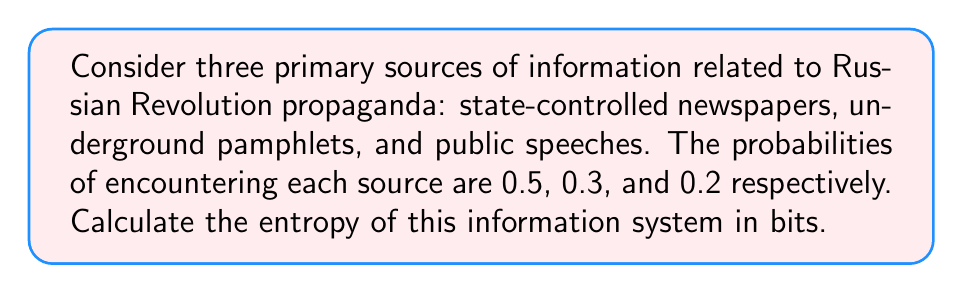Show me your answer to this math problem. To calculate the entropy of this information system, we'll use Shannon's entropy formula:

$$H = -\sum_{i=1}^{n} p_i \log_2(p_i)$$

Where:
- $H$ is the entropy in bits
- $p_i$ is the probability of each information source
- $n$ is the number of sources

Let's calculate for each source:

1. State-controlled newspapers ($p_1 = 0.5$):
   $$-0.5 \log_2(0.5) = 0.5$$

2. Underground pamphlets ($p_2 = 0.3$):
   $$-0.3 \log_2(0.3) \approx 0.521$$

3. Public speeches ($p_3 = 0.2$):
   $$-0.2 \log_2(0.2) \approx 0.464$$

Now, sum these values:

$$H = 0.5 + 0.521 + 0.464 = 1.485$$

Therefore, the entropy of this information system is approximately 1.485 bits.
Answer: 1.485 bits 